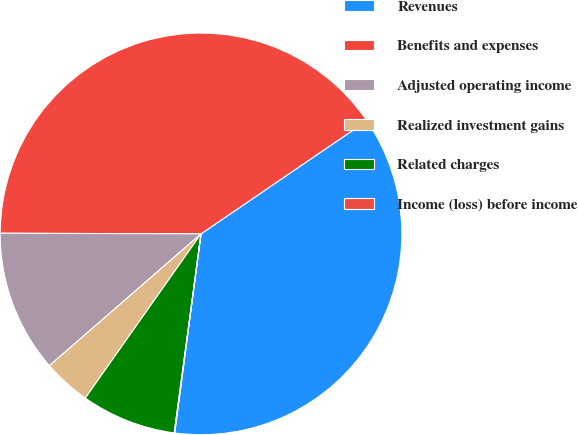<chart> <loc_0><loc_0><loc_500><loc_500><pie_chart><fcel>Revenues<fcel>Benefits and expenses<fcel>Adjusted operating income<fcel>Realized investment gains<fcel>Related charges<fcel>Income (loss) before income<nl><fcel>36.62%<fcel>40.42%<fcel>11.44%<fcel>3.84%<fcel>7.64%<fcel>0.04%<nl></chart> 